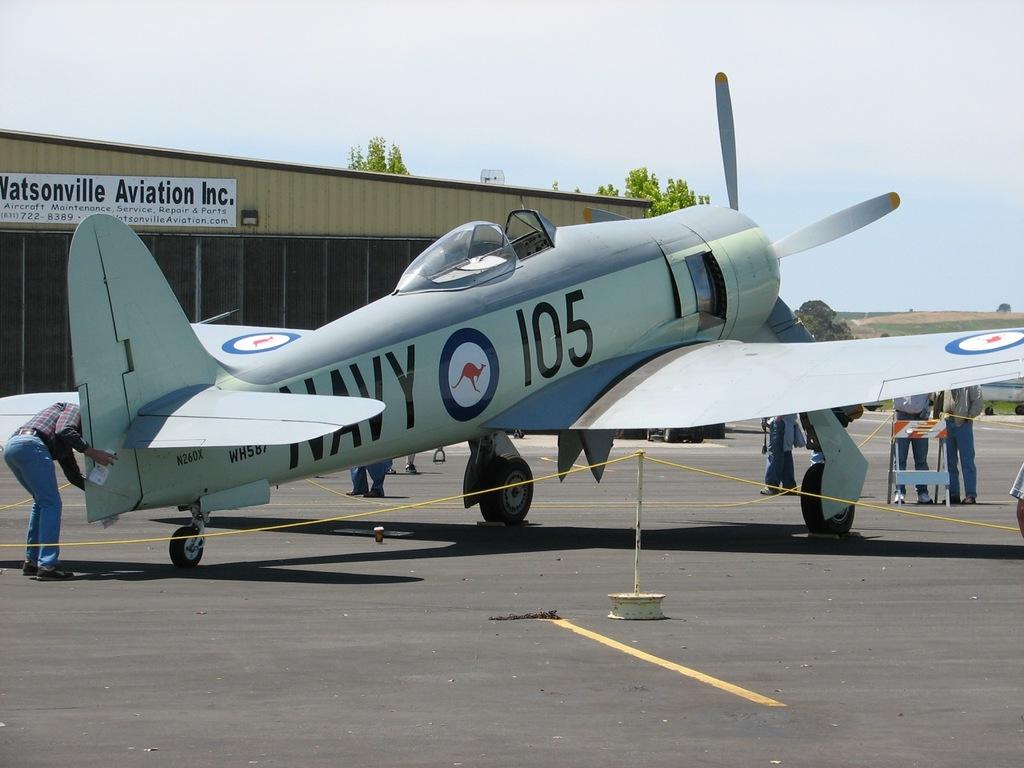What is the plane number?
Provide a succinct answer. 105. What branch of the military is on the plane?
Your answer should be very brief. Navy. 